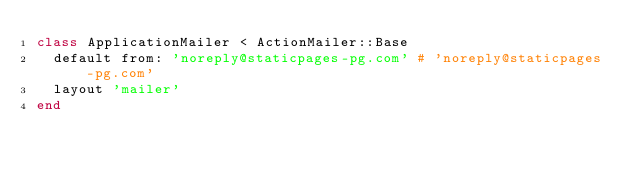<code> <loc_0><loc_0><loc_500><loc_500><_Ruby_>class ApplicationMailer < ActionMailer::Base
  default from: 'noreply@staticpages-pg.com' # 'noreply@staticpages-pg.com'
  layout 'mailer'
end
</code> 